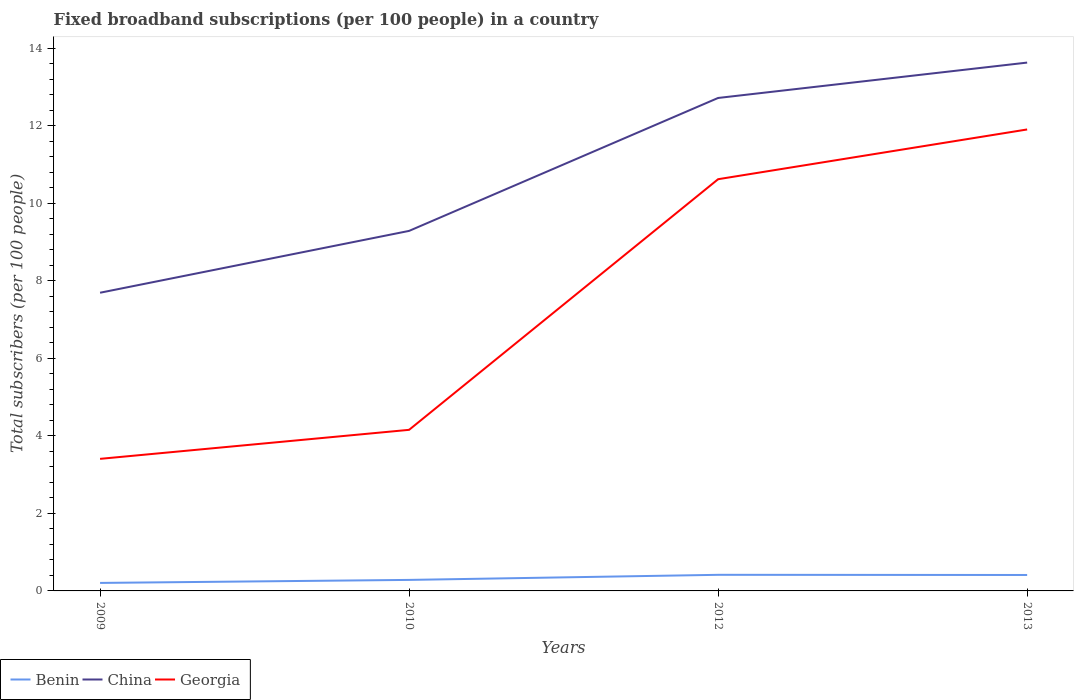Is the number of lines equal to the number of legend labels?
Offer a very short reply. Yes. Across all years, what is the maximum number of broadband subscriptions in Georgia?
Ensure brevity in your answer.  3.41. In which year was the number of broadband subscriptions in China maximum?
Provide a succinct answer. 2009. What is the total number of broadband subscriptions in Benin in the graph?
Offer a very short reply. -0.13. What is the difference between the highest and the second highest number of broadband subscriptions in Georgia?
Offer a very short reply. 8.5. Is the number of broadband subscriptions in China strictly greater than the number of broadband subscriptions in Benin over the years?
Offer a terse response. No. Does the graph contain grids?
Make the answer very short. No. What is the title of the graph?
Keep it short and to the point. Fixed broadband subscriptions (per 100 people) in a country. What is the label or title of the Y-axis?
Your response must be concise. Total subscribers (per 100 people). What is the Total subscribers (per 100 people) of Benin in 2009?
Offer a very short reply. 0.21. What is the Total subscribers (per 100 people) of China in 2009?
Your answer should be very brief. 7.69. What is the Total subscribers (per 100 people) in Georgia in 2009?
Offer a terse response. 3.41. What is the Total subscribers (per 100 people) in Benin in 2010?
Give a very brief answer. 0.28. What is the Total subscribers (per 100 people) in China in 2010?
Your answer should be very brief. 9.29. What is the Total subscribers (per 100 people) in Georgia in 2010?
Your answer should be compact. 4.16. What is the Total subscribers (per 100 people) in Benin in 2012?
Your answer should be very brief. 0.42. What is the Total subscribers (per 100 people) of China in 2012?
Your response must be concise. 12.72. What is the Total subscribers (per 100 people) of Georgia in 2012?
Offer a terse response. 10.62. What is the Total subscribers (per 100 people) in Benin in 2013?
Ensure brevity in your answer.  0.41. What is the Total subscribers (per 100 people) in China in 2013?
Make the answer very short. 13.63. What is the Total subscribers (per 100 people) of Georgia in 2013?
Provide a short and direct response. 11.91. Across all years, what is the maximum Total subscribers (per 100 people) in Benin?
Your response must be concise. 0.42. Across all years, what is the maximum Total subscribers (per 100 people) of China?
Your answer should be compact. 13.63. Across all years, what is the maximum Total subscribers (per 100 people) of Georgia?
Your response must be concise. 11.91. Across all years, what is the minimum Total subscribers (per 100 people) of Benin?
Make the answer very short. 0.21. Across all years, what is the minimum Total subscribers (per 100 people) of China?
Your answer should be very brief. 7.69. Across all years, what is the minimum Total subscribers (per 100 people) in Georgia?
Keep it short and to the point. 3.41. What is the total Total subscribers (per 100 people) of Benin in the graph?
Your response must be concise. 1.32. What is the total Total subscribers (per 100 people) of China in the graph?
Offer a terse response. 43.34. What is the total Total subscribers (per 100 people) of Georgia in the graph?
Your answer should be compact. 30.1. What is the difference between the Total subscribers (per 100 people) of Benin in 2009 and that in 2010?
Keep it short and to the point. -0.08. What is the difference between the Total subscribers (per 100 people) in China in 2009 and that in 2010?
Your answer should be compact. -1.6. What is the difference between the Total subscribers (per 100 people) in Georgia in 2009 and that in 2010?
Offer a terse response. -0.75. What is the difference between the Total subscribers (per 100 people) of Benin in 2009 and that in 2012?
Provide a succinct answer. -0.21. What is the difference between the Total subscribers (per 100 people) of China in 2009 and that in 2012?
Ensure brevity in your answer.  -5.03. What is the difference between the Total subscribers (per 100 people) in Georgia in 2009 and that in 2012?
Your answer should be very brief. -7.22. What is the difference between the Total subscribers (per 100 people) of Benin in 2009 and that in 2013?
Provide a short and direct response. -0.21. What is the difference between the Total subscribers (per 100 people) in China in 2009 and that in 2013?
Your answer should be very brief. -5.94. What is the difference between the Total subscribers (per 100 people) of Georgia in 2009 and that in 2013?
Offer a very short reply. -8.5. What is the difference between the Total subscribers (per 100 people) in Benin in 2010 and that in 2012?
Give a very brief answer. -0.13. What is the difference between the Total subscribers (per 100 people) in China in 2010 and that in 2012?
Your response must be concise. -3.43. What is the difference between the Total subscribers (per 100 people) in Georgia in 2010 and that in 2012?
Provide a short and direct response. -6.47. What is the difference between the Total subscribers (per 100 people) of Benin in 2010 and that in 2013?
Your answer should be very brief. -0.13. What is the difference between the Total subscribers (per 100 people) of China in 2010 and that in 2013?
Provide a short and direct response. -4.34. What is the difference between the Total subscribers (per 100 people) of Georgia in 2010 and that in 2013?
Offer a very short reply. -7.75. What is the difference between the Total subscribers (per 100 people) of Benin in 2012 and that in 2013?
Your answer should be compact. 0. What is the difference between the Total subscribers (per 100 people) in China in 2012 and that in 2013?
Your answer should be compact. -0.91. What is the difference between the Total subscribers (per 100 people) of Georgia in 2012 and that in 2013?
Your answer should be compact. -1.28. What is the difference between the Total subscribers (per 100 people) of Benin in 2009 and the Total subscribers (per 100 people) of China in 2010?
Keep it short and to the point. -9.08. What is the difference between the Total subscribers (per 100 people) in Benin in 2009 and the Total subscribers (per 100 people) in Georgia in 2010?
Ensure brevity in your answer.  -3.95. What is the difference between the Total subscribers (per 100 people) in China in 2009 and the Total subscribers (per 100 people) in Georgia in 2010?
Your answer should be compact. 3.54. What is the difference between the Total subscribers (per 100 people) in Benin in 2009 and the Total subscribers (per 100 people) in China in 2012?
Your answer should be very brief. -12.52. What is the difference between the Total subscribers (per 100 people) in Benin in 2009 and the Total subscribers (per 100 people) in Georgia in 2012?
Provide a short and direct response. -10.42. What is the difference between the Total subscribers (per 100 people) in China in 2009 and the Total subscribers (per 100 people) in Georgia in 2012?
Your answer should be very brief. -2.93. What is the difference between the Total subscribers (per 100 people) of Benin in 2009 and the Total subscribers (per 100 people) of China in 2013?
Your response must be concise. -13.43. What is the difference between the Total subscribers (per 100 people) of Benin in 2009 and the Total subscribers (per 100 people) of Georgia in 2013?
Your response must be concise. -11.7. What is the difference between the Total subscribers (per 100 people) of China in 2009 and the Total subscribers (per 100 people) of Georgia in 2013?
Give a very brief answer. -4.21. What is the difference between the Total subscribers (per 100 people) in Benin in 2010 and the Total subscribers (per 100 people) in China in 2012?
Give a very brief answer. -12.44. What is the difference between the Total subscribers (per 100 people) in Benin in 2010 and the Total subscribers (per 100 people) in Georgia in 2012?
Offer a very short reply. -10.34. What is the difference between the Total subscribers (per 100 people) of China in 2010 and the Total subscribers (per 100 people) of Georgia in 2012?
Make the answer very short. -1.33. What is the difference between the Total subscribers (per 100 people) in Benin in 2010 and the Total subscribers (per 100 people) in China in 2013?
Provide a succinct answer. -13.35. What is the difference between the Total subscribers (per 100 people) of Benin in 2010 and the Total subscribers (per 100 people) of Georgia in 2013?
Give a very brief answer. -11.62. What is the difference between the Total subscribers (per 100 people) in China in 2010 and the Total subscribers (per 100 people) in Georgia in 2013?
Offer a terse response. -2.62. What is the difference between the Total subscribers (per 100 people) of Benin in 2012 and the Total subscribers (per 100 people) of China in 2013?
Provide a succinct answer. -13.22. What is the difference between the Total subscribers (per 100 people) of Benin in 2012 and the Total subscribers (per 100 people) of Georgia in 2013?
Keep it short and to the point. -11.49. What is the difference between the Total subscribers (per 100 people) of China in 2012 and the Total subscribers (per 100 people) of Georgia in 2013?
Your answer should be very brief. 0.81. What is the average Total subscribers (per 100 people) in Benin per year?
Make the answer very short. 0.33. What is the average Total subscribers (per 100 people) of China per year?
Ensure brevity in your answer.  10.84. What is the average Total subscribers (per 100 people) of Georgia per year?
Give a very brief answer. 7.52. In the year 2009, what is the difference between the Total subscribers (per 100 people) in Benin and Total subscribers (per 100 people) in China?
Your answer should be compact. -7.49. In the year 2009, what is the difference between the Total subscribers (per 100 people) in Benin and Total subscribers (per 100 people) in Georgia?
Keep it short and to the point. -3.2. In the year 2009, what is the difference between the Total subscribers (per 100 people) of China and Total subscribers (per 100 people) of Georgia?
Your answer should be very brief. 4.29. In the year 2010, what is the difference between the Total subscribers (per 100 people) in Benin and Total subscribers (per 100 people) in China?
Offer a very short reply. -9.01. In the year 2010, what is the difference between the Total subscribers (per 100 people) in Benin and Total subscribers (per 100 people) in Georgia?
Make the answer very short. -3.87. In the year 2010, what is the difference between the Total subscribers (per 100 people) of China and Total subscribers (per 100 people) of Georgia?
Offer a very short reply. 5.13. In the year 2012, what is the difference between the Total subscribers (per 100 people) of Benin and Total subscribers (per 100 people) of China?
Offer a very short reply. -12.31. In the year 2012, what is the difference between the Total subscribers (per 100 people) in Benin and Total subscribers (per 100 people) in Georgia?
Your answer should be compact. -10.21. In the year 2012, what is the difference between the Total subscribers (per 100 people) in China and Total subscribers (per 100 people) in Georgia?
Your answer should be compact. 2.1. In the year 2013, what is the difference between the Total subscribers (per 100 people) in Benin and Total subscribers (per 100 people) in China?
Keep it short and to the point. -13.22. In the year 2013, what is the difference between the Total subscribers (per 100 people) of Benin and Total subscribers (per 100 people) of Georgia?
Your answer should be very brief. -11.5. In the year 2013, what is the difference between the Total subscribers (per 100 people) in China and Total subscribers (per 100 people) in Georgia?
Give a very brief answer. 1.73. What is the ratio of the Total subscribers (per 100 people) in Benin in 2009 to that in 2010?
Provide a short and direct response. 0.73. What is the ratio of the Total subscribers (per 100 people) in China in 2009 to that in 2010?
Ensure brevity in your answer.  0.83. What is the ratio of the Total subscribers (per 100 people) in Georgia in 2009 to that in 2010?
Your answer should be very brief. 0.82. What is the ratio of the Total subscribers (per 100 people) in Benin in 2009 to that in 2012?
Offer a terse response. 0.5. What is the ratio of the Total subscribers (per 100 people) in China in 2009 to that in 2012?
Offer a terse response. 0.6. What is the ratio of the Total subscribers (per 100 people) of Georgia in 2009 to that in 2012?
Provide a succinct answer. 0.32. What is the ratio of the Total subscribers (per 100 people) in Benin in 2009 to that in 2013?
Give a very brief answer. 0.5. What is the ratio of the Total subscribers (per 100 people) of China in 2009 to that in 2013?
Your answer should be very brief. 0.56. What is the ratio of the Total subscribers (per 100 people) in Georgia in 2009 to that in 2013?
Provide a short and direct response. 0.29. What is the ratio of the Total subscribers (per 100 people) in Benin in 2010 to that in 2012?
Offer a very short reply. 0.68. What is the ratio of the Total subscribers (per 100 people) in China in 2010 to that in 2012?
Ensure brevity in your answer.  0.73. What is the ratio of the Total subscribers (per 100 people) in Georgia in 2010 to that in 2012?
Your response must be concise. 0.39. What is the ratio of the Total subscribers (per 100 people) of Benin in 2010 to that in 2013?
Your response must be concise. 0.69. What is the ratio of the Total subscribers (per 100 people) of China in 2010 to that in 2013?
Ensure brevity in your answer.  0.68. What is the ratio of the Total subscribers (per 100 people) of Georgia in 2010 to that in 2013?
Offer a very short reply. 0.35. What is the ratio of the Total subscribers (per 100 people) of Benin in 2012 to that in 2013?
Offer a terse response. 1.01. What is the ratio of the Total subscribers (per 100 people) of China in 2012 to that in 2013?
Provide a succinct answer. 0.93. What is the ratio of the Total subscribers (per 100 people) in Georgia in 2012 to that in 2013?
Offer a terse response. 0.89. What is the difference between the highest and the second highest Total subscribers (per 100 people) of Benin?
Give a very brief answer. 0. What is the difference between the highest and the second highest Total subscribers (per 100 people) of China?
Provide a short and direct response. 0.91. What is the difference between the highest and the second highest Total subscribers (per 100 people) of Georgia?
Provide a succinct answer. 1.28. What is the difference between the highest and the lowest Total subscribers (per 100 people) in Benin?
Your response must be concise. 0.21. What is the difference between the highest and the lowest Total subscribers (per 100 people) of China?
Your answer should be compact. 5.94. What is the difference between the highest and the lowest Total subscribers (per 100 people) of Georgia?
Offer a very short reply. 8.5. 